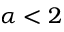Convert formula to latex. <formula><loc_0><loc_0><loc_500><loc_500>\alpha < 2</formula> 